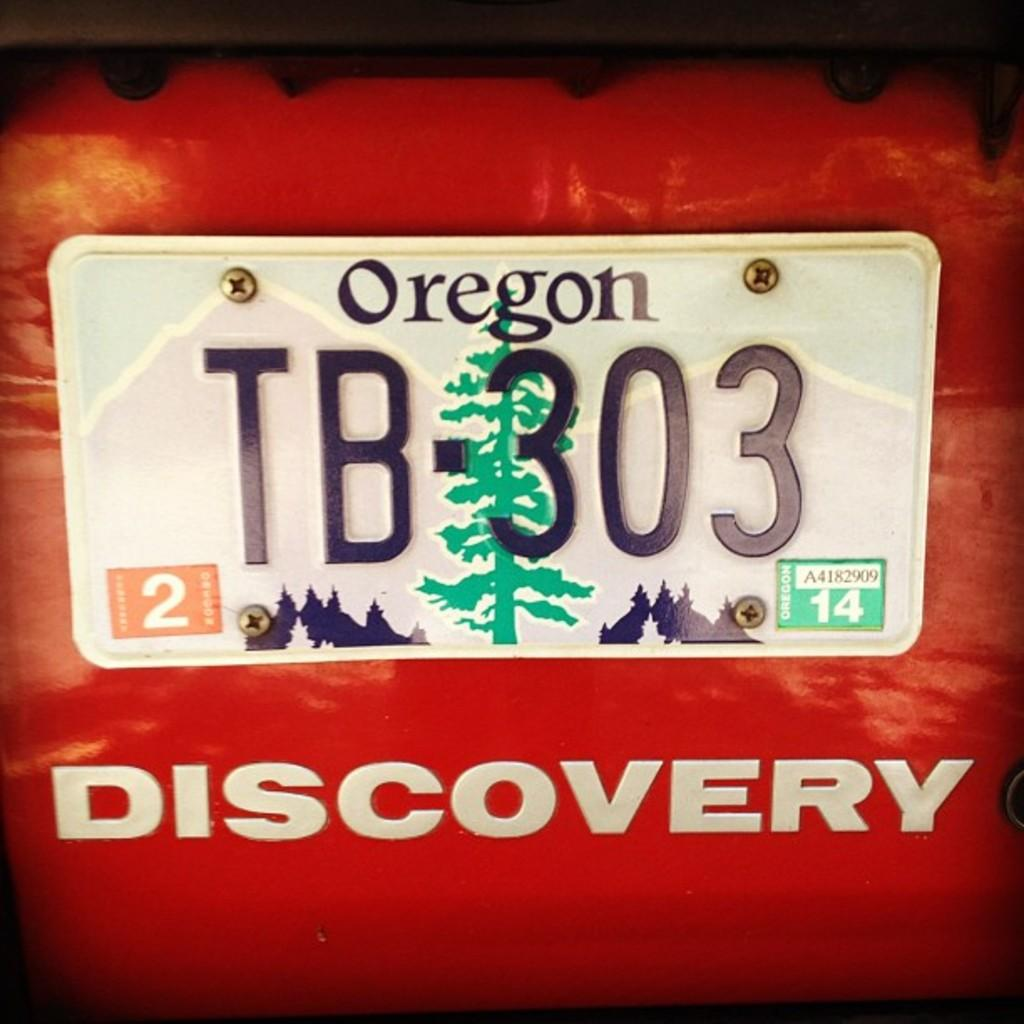What can be seen on the car in the image? There is a number plate visible on the car in the image. What word is written at the bottom of the image? The word "discovery" is visible at the bottom of the image. What type of vehicle is present in the image? There is a car in the image. What type of roof can be seen on the car in the image? There is no roof visible in the image, as it only shows a number plate and the word "discovery." How many loaves of bread are present in the image? There is no bread present in the image. 